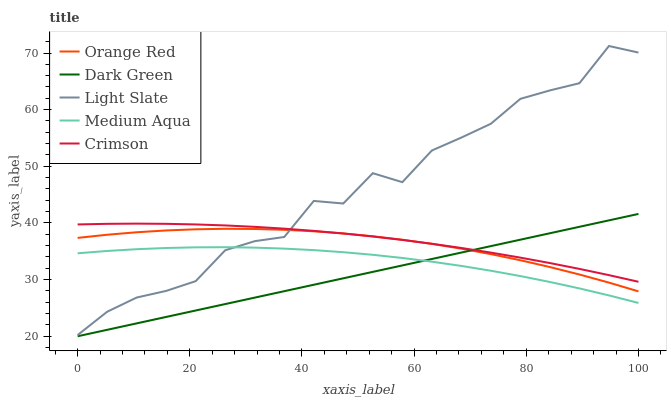Does Dark Green have the minimum area under the curve?
Answer yes or no. Yes. Does Light Slate have the maximum area under the curve?
Answer yes or no. Yes. Does Crimson have the minimum area under the curve?
Answer yes or no. No. Does Crimson have the maximum area under the curve?
Answer yes or no. No. Is Dark Green the smoothest?
Answer yes or no. Yes. Is Light Slate the roughest?
Answer yes or no. Yes. Is Crimson the smoothest?
Answer yes or no. No. Is Crimson the roughest?
Answer yes or no. No. Does Dark Green have the lowest value?
Answer yes or no. Yes. Does Medium Aqua have the lowest value?
Answer yes or no. No. Does Light Slate have the highest value?
Answer yes or no. Yes. Does Crimson have the highest value?
Answer yes or no. No. Is Dark Green less than Light Slate?
Answer yes or no. Yes. Is Orange Red greater than Medium Aqua?
Answer yes or no. Yes. Does Orange Red intersect Light Slate?
Answer yes or no. Yes. Is Orange Red less than Light Slate?
Answer yes or no. No. Is Orange Red greater than Light Slate?
Answer yes or no. No. Does Dark Green intersect Light Slate?
Answer yes or no. No. 